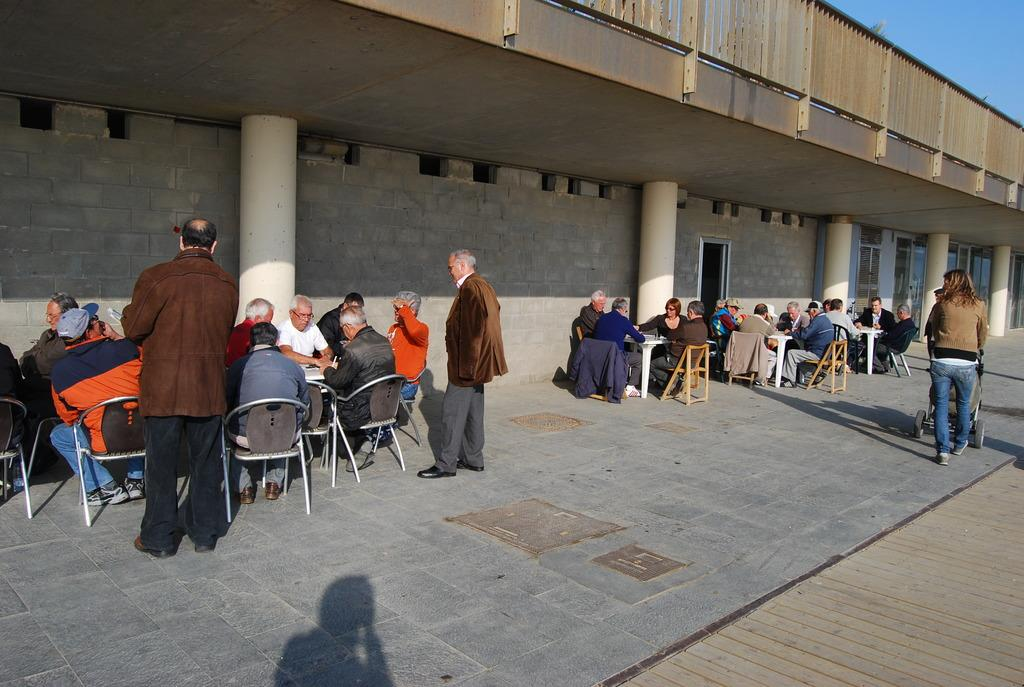What are the people in the image doing while sitting on the chair? There is a group of people sitting on a chair in front of a table in the image. Can you describe the people who are not sitting in the image? There are people standing in the image. What are the people doing who are not sitting or standing in the image? There are people walking on the road in the image. What type of structure is visible in the background of the image? There is a building with a fence in the image. What type of invention can be seen in the hands of the people walking on the road? There is no invention visible in the hands of the people walking on the road in the image. Can you describe the cave where the people are sitting in the image? There is no cave present in the image; the people are sitting on a chair in front of a table. 